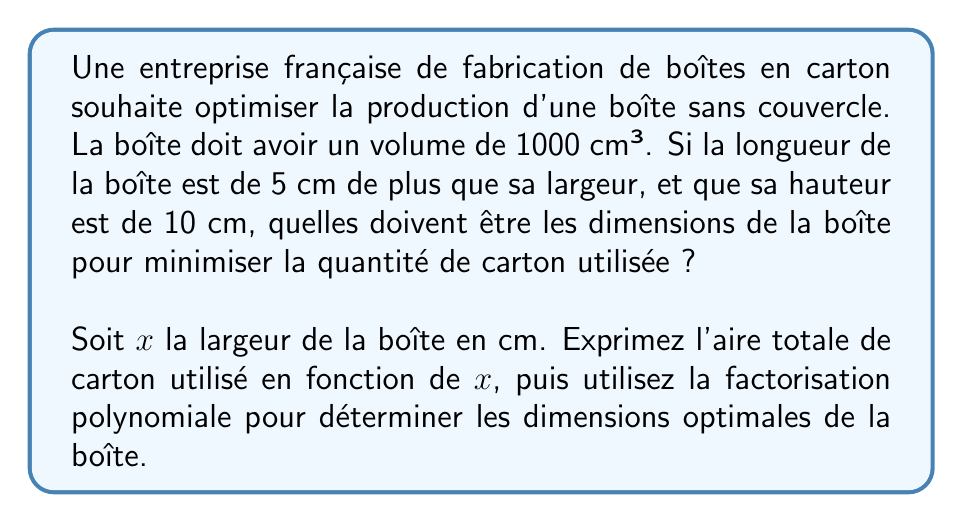Could you help me with this problem? Pour résoudre ce problème d'optimisation, suivons ces étapes :

1) D'abord, exprimons les dimensions de la boîte en fonction de $x$ :
   - Largeur : $x$ cm
   - Longueur : $(x + 5)$ cm
   - Hauteur : 10 cm

2) Le volume de la boîte doit être de 1000 cm³, donc :
   $x(x+5)(10) = 1000$
   $10x^2 + 50x = 1000$
   $x^2 + 5x = 100$

3) L'aire totale de carton utilisé sera la somme des aires des 5 faces de la boîte :
   $A = x(x+5) + 2x(10) + 2(x+5)(10)$
   $A = x^2 + 5x + 20x + 20x + 100$
   $A = x^2 + 45x + 100$

4) Pour trouver le minimum de cette fonction, nous devons trouver sa dérivée et l'égaler à zéro :
   $A' = 2x + 45$
   $2x + 45 = 0$
   $x = -22.5$

   Cependant, cette valeur n'a pas de sens dans notre contexte.

5) Revenons à l'équation du volume : $x^2 + 5x = 100$
   Réorganisons-la : $x^2 + 5x - 100 = 0$

6) Factorisons ce polynôme :
   $(x + 10)(x - 5) = 0$

   Les solutions sont $x = 5$ ou $x = -10$. La solution négative n'a pas de sens ici.

7) Donc, la largeur optimale est $x = 5$ cm.
   La longueur sera alors $5 + 5 = 10$ cm.

8) Vérifions le volume : $5 * 10 * 10 = 500$ cm³, ce qui correspond bien à 1000 cm³.

Ainsi, les dimensions optimales de la boîte sont :
- Largeur : 5 cm
- Longueur : 10 cm
- Hauteur : 10 cm
Answer: Les dimensions optimales de la boîte sont : 5 cm de largeur, 10 cm de longueur et 10 cm de hauteur. 